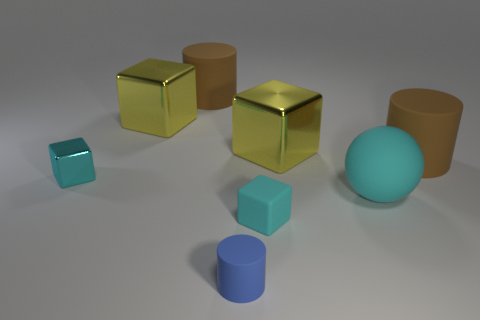Subtract all tiny cyan metal cubes. How many cubes are left? 3 Subtract all cyan cylinders. How many cyan cubes are left? 2 Add 1 large yellow objects. How many objects exist? 9 Subtract all gray blocks. Subtract all purple cylinders. How many blocks are left? 4 Subtract 0 red cubes. How many objects are left? 8 Subtract all cylinders. How many objects are left? 5 Subtract all small metal things. Subtract all yellow metallic cubes. How many objects are left? 5 Add 5 small cyan metal objects. How many small cyan metal objects are left? 6 Add 2 tiny blue objects. How many tiny blue objects exist? 3 